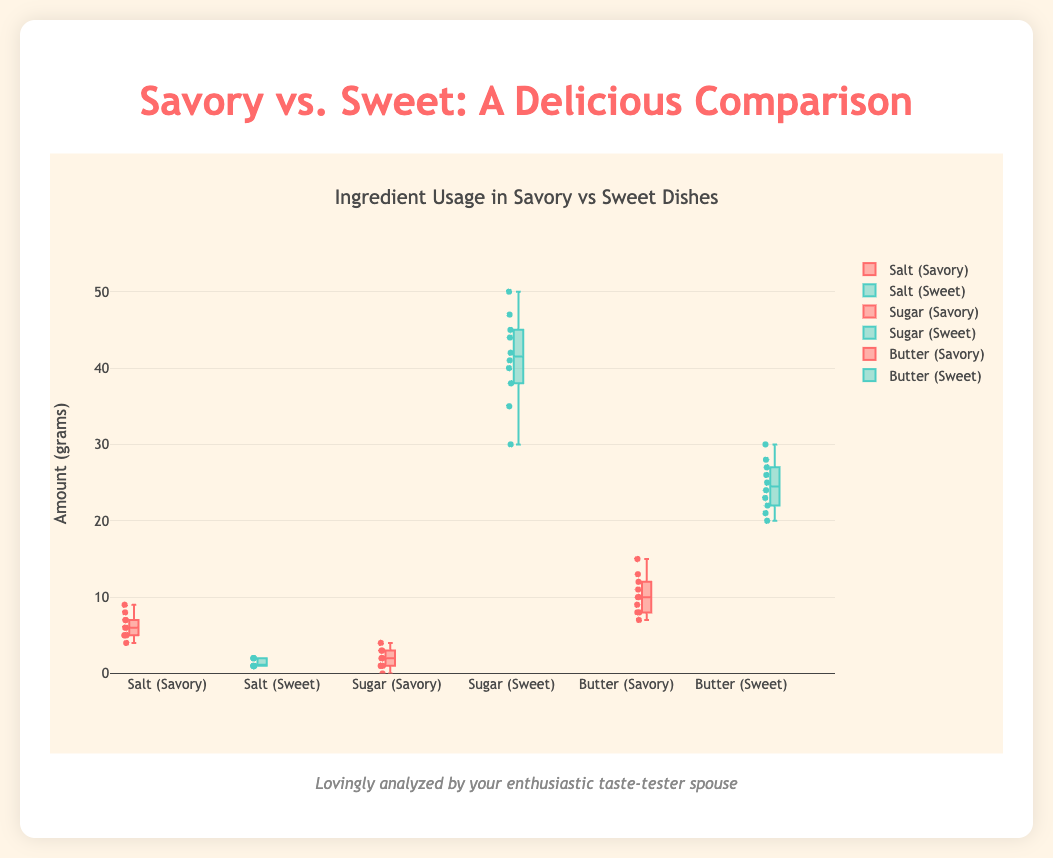What is the title of the figure? The title of the figure is usually located at the top and summarizes the content of the chart. In this case, it specifies the comparison between savory and sweet ingredients.
Answer: Ingredient Usage in Savory vs Sweet Dishes What is the unit of measurement for the ingredient amounts? The y-axis label indicates the unit of measurement used for the ingredient amounts.
Answer: grams Which ingredient has the highest median value in sweet dishes? By examining the box plots of sweet dishes, we can find the median line in the middle of each box. The ingredient with the highest median line is Sugar.
Answer: Sugar How does the median amount of Sugar in savory dishes compare to sweet dishes? By comparing the median lines on the Sugar box plots for both savory and sweet dishes, we observe that the median is lower for savory dishes compared to sweet dishes.
Answer: Lower What color represents sweet dish data in the figure? The colors assigned to sweet and savory data are usually indicated in the figure or can be deduced from the color of the box plots. The sweet dish data is colored in a distinct color (e.g., cyan).
Answer: cyan Which dish type uses more Salt on average? By comparing the average lines or by visually estimating the central tendency for Salt in both dish types, we see that savory dishes use more Salt.
Answer: Savory What is the interquartile range (IQR) for Butter in sweet dishes? The IQR is the range between the first quartile (Q1) and third quartile (Q3) in the box plot. For Butter in sweet dishes, these values are at approximately 22 and 27 grams. The IQR is 27 - 22.
Answer: 5 grams How many grams of Salt are typically used in savory dishes compared to sweet dishes? The difference in median values of Salt between savory and sweet dishes can be noted. Savory dishes typically use more Salt, with values around 6 grams compared to 1-2 grams in sweet dishes.
Answer: Savory: ~6 grams, Sweet: ~1-2 grams What can be inferred about the variability of Butter usage in savory vs sweet dishes? By looking at the spread of the data points and the length of the whiskers in the box plots, we can infer that the variability is higher in savory dishes than in sweet dishes for Butter.
Answer: Higher variability in savory dishes What is the median amount of Butter used in savory dishes? Identifying the median line within the box plot for Butter in savory dishes, we can find that it is around 10 grams.
Answer: 10 grams 